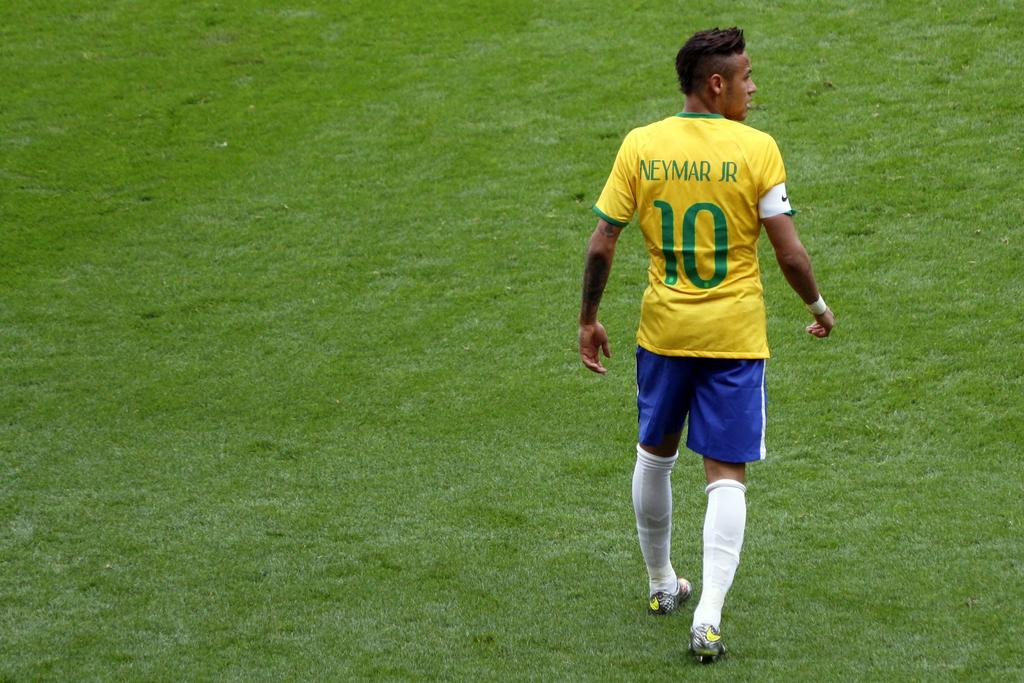Provide a one-sentence caption for the provided image. Player number 10 walks across the grassy field. 